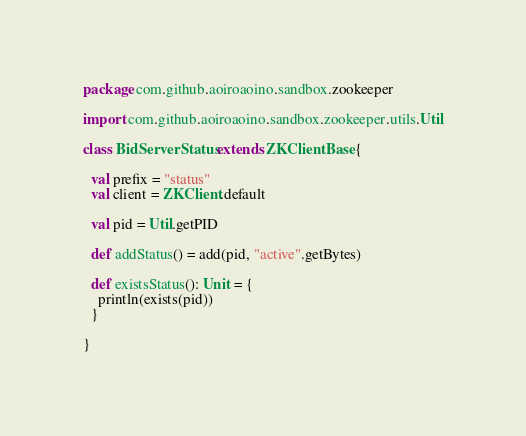Convert code to text. <code><loc_0><loc_0><loc_500><loc_500><_Scala_>package com.github.aoiroaoino.sandbox.zookeeper

import com.github.aoiroaoino.sandbox.zookeeper.utils.Util

class BidServerStatus extends ZKClientBase {

  val prefix = "status"
  val client = ZKClient.default

  val pid = Util.getPID

  def addStatus() = add(pid, "active".getBytes)

  def existsStatus(): Unit = {
    println(exists(pid))
  }

}
</code> 